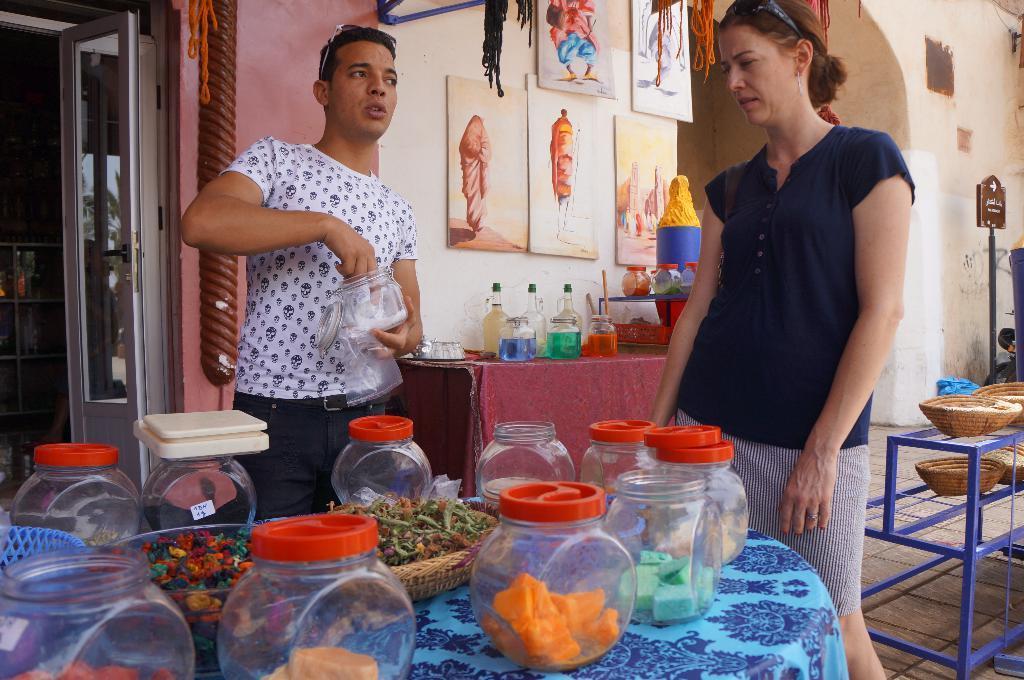Can you describe this image briefly? In this image there are some boxes with some objects in it, trays with some items in it on the table, and there are two persons standing , bottles and boxes on the table, frames attached to the wall, door, trays on the steel rack. 